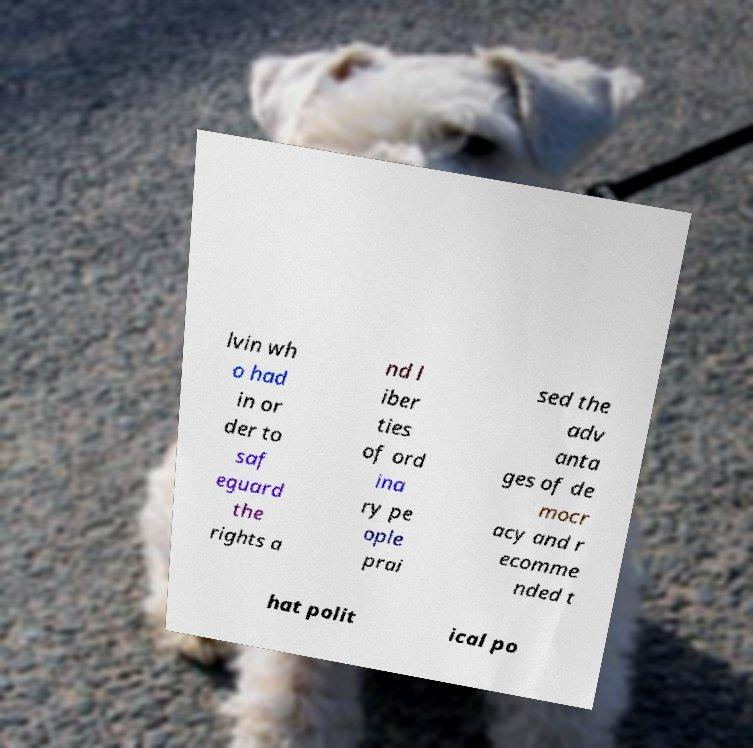Could you assist in decoding the text presented in this image and type it out clearly? lvin wh o had in or der to saf eguard the rights a nd l iber ties of ord ina ry pe ople prai sed the adv anta ges of de mocr acy and r ecomme nded t hat polit ical po 